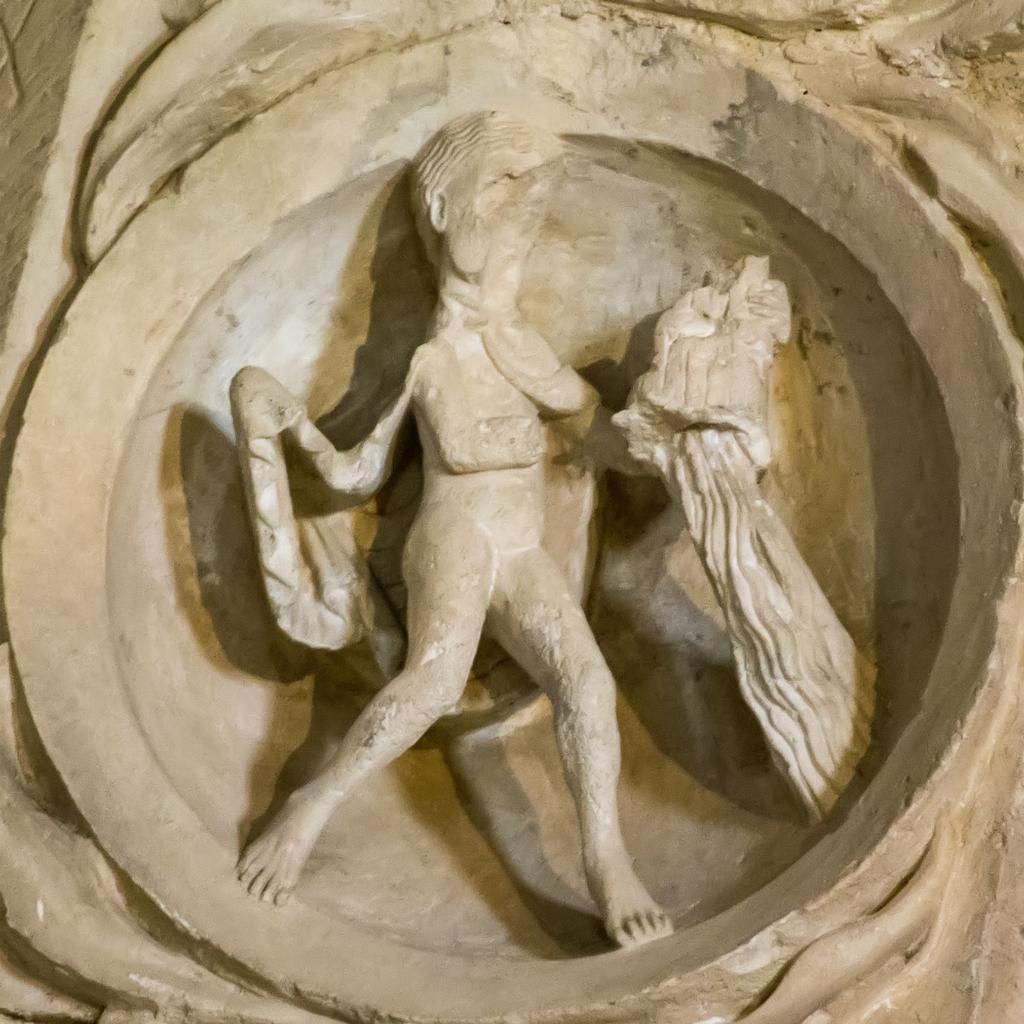What is the main subject in the middle of the image? There is a statue in the middle of the image. How many holes can be seen in the statue in the image? There is no mention of any holes in the statue in the image, so we cannot determine the number of holes. 